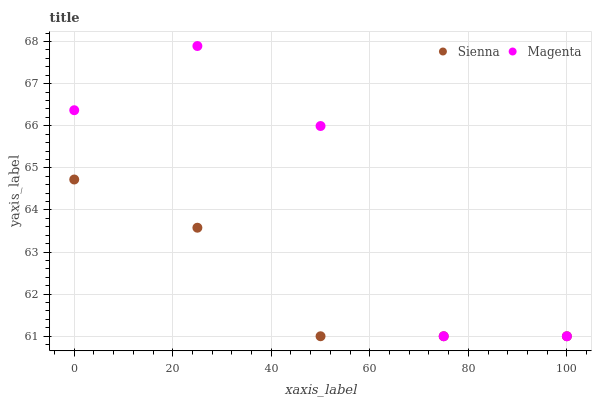Does Sienna have the minimum area under the curve?
Answer yes or no. Yes. Does Magenta have the maximum area under the curve?
Answer yes or no. Yes. Does Magenta have the minimum area under the curve?
Answer yes or no. No. Is Sienna the smoothest?
Answer yes or no. Yes. Is Magenta the roughest?
Answer yes or no. Yes. Is Magenta the smoothest?
Answer yes or no. No. Does Sienna have the lowest value?
Answer yes or no. Yes. Does Magenta have the highest value?
Answer yes or no. Yes. Does Sienna intersect Magenta?
Answer yes or no. Yes. Is Sienna less than Magenta?
Answer yes or no. No. Is Sienna greater than Magenta?
Answer yes or no. No. 